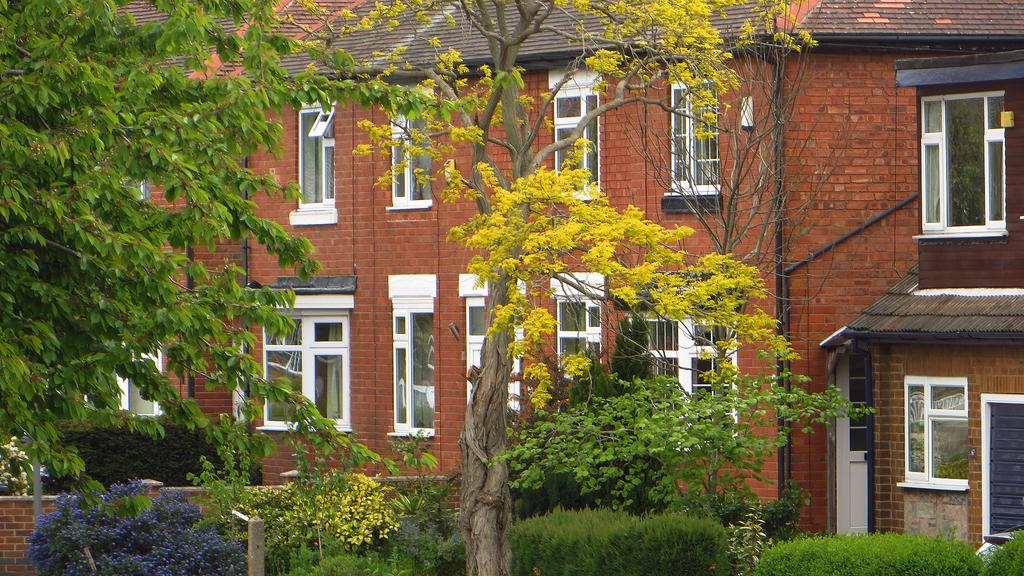What type of structures can be seen in the image? There are houses in the image. What is located in front of the houses? There are bushes and trees in front of the houses. What type of fence is present in the image? There is a brick fence in the image. What type of news can be seen on the kitten in the image? There is no kitten or news present in the image. What type of religious symbol can be seen in the image? There is no religious symbol present in the image. 